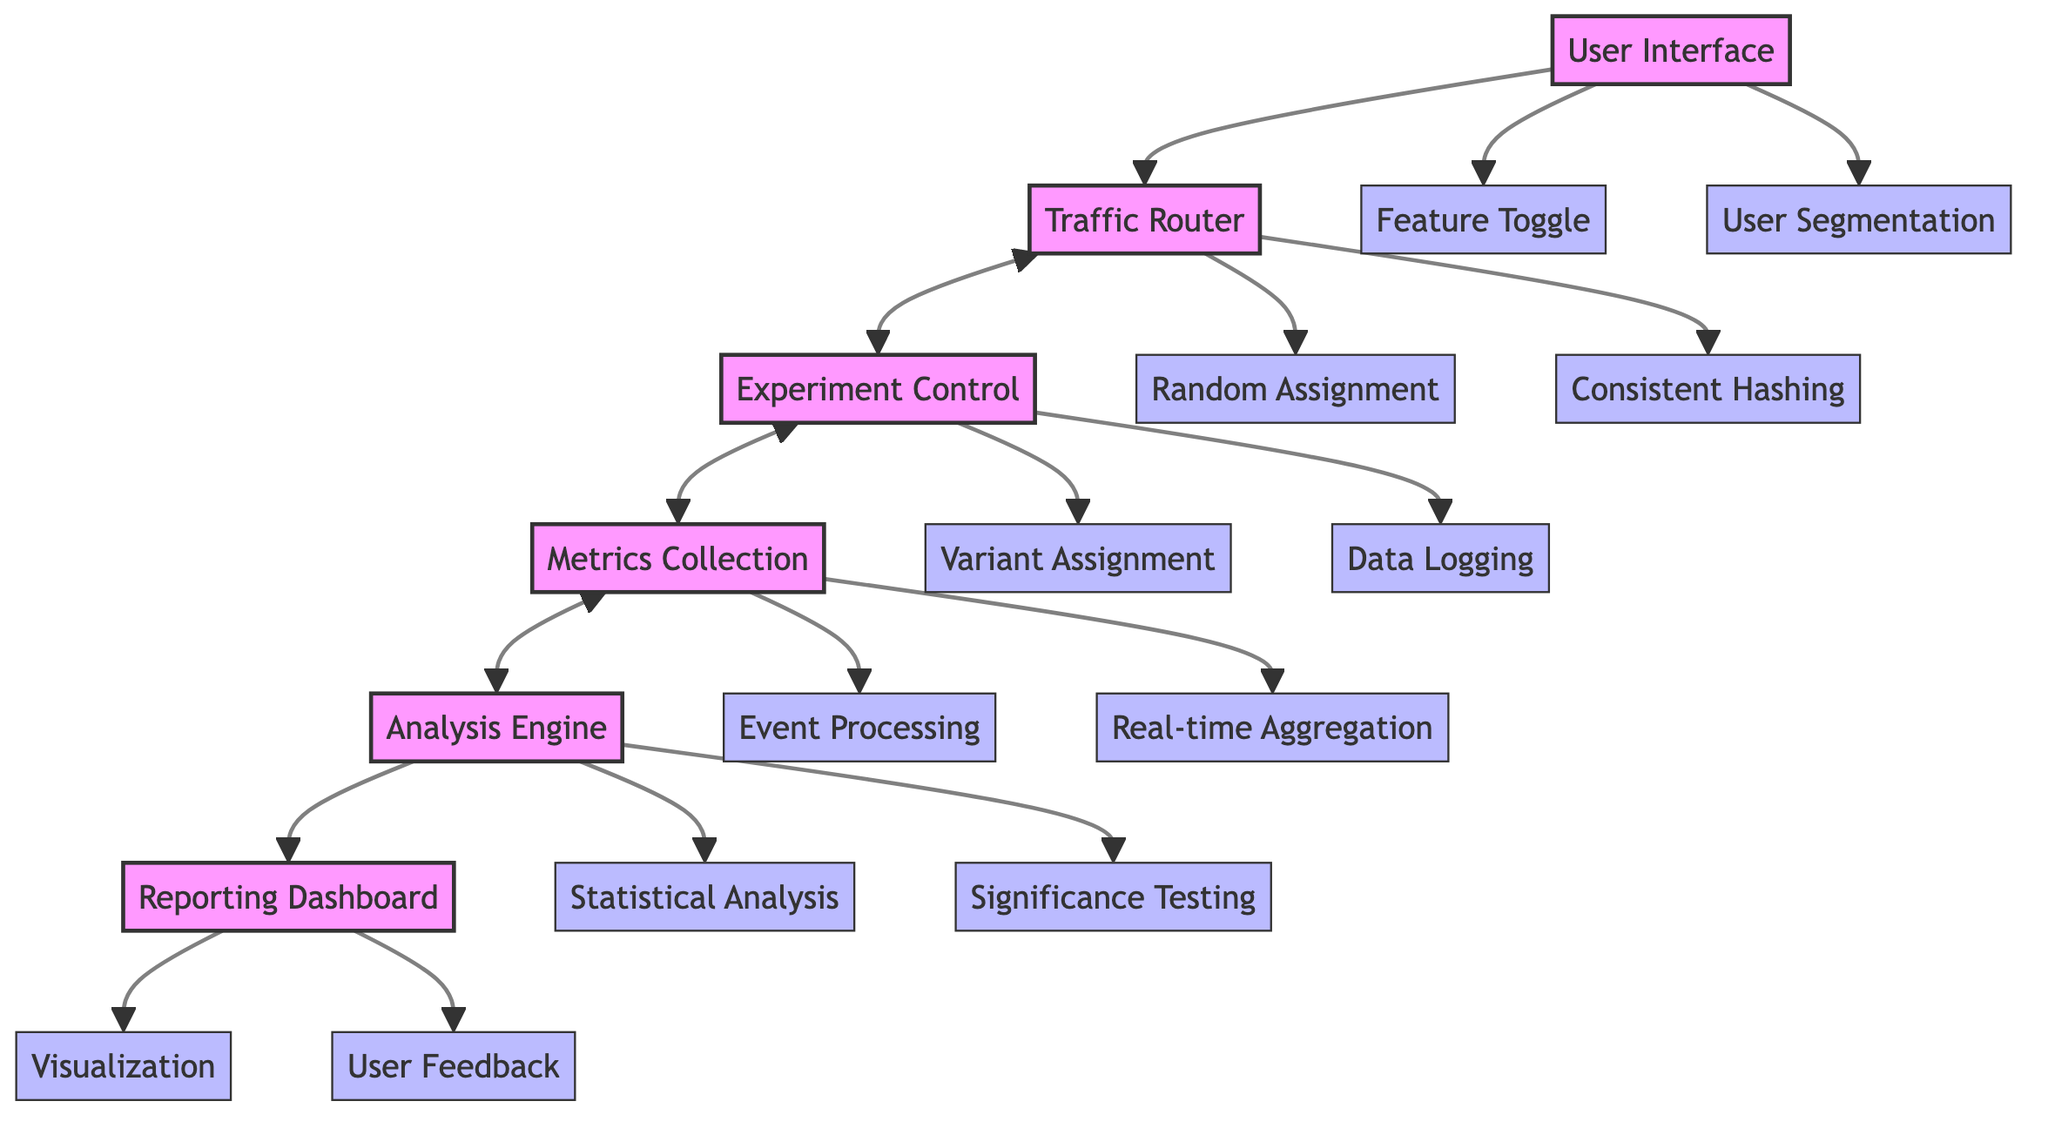What is the main function of the User Interface? The User Interface primarily allows for the implementation of a Feature Toggle and User Segmentation, which are its main attributes. It interacts directly with the Traffic Router.
Answer: Feature Toggle, User Segmentation How many main components are present in the diagram? By counting the components depicted in the diagram, there are six main components: User Interface, Traffic Router, Experiment Control, Metrics Collection, Analysis Engine, and Reporting Dashboard.
Answer: Six Which component is responsible for Data Logging? The Experiment Control component is responsible for Data Logging, as indicated by its listed attributes. It has a bidirectional interaction with the Traffic Router.
Answer: Experiment Control What does the Analysis Engine interact with? The Analysis Engine interacts with both the Metrics Collection and the Reporting Dashboard components, as shown by the arrows connecting them in the diagram.
Answer: Metrics Collection, Reporting Dashboard What are the two attributes of the Metrics Collection component? The two attributes associated with the Metrics Collection component are Event Processing and Real-time Aggregation, which are indicated in the diagram.
Answer: Event Processing, Real-time Aggregation How are the Traffic Router and Experiment Control connected? The Traffic Router and Experiment Control are connected by a bidirectional interaction arrow, meaning they communicate back and forth in the framework process.
Answer: Bidirectional interaction Which attribute is part of the User Interface? The attributes associated with the User Interface include Feature Toggle and User Segmentation, showing how users can interact with features.
Answer: Feature Toggle What key function does the Reporting Dashboard provide? The Reporting Dashboard provides Visualization and User Feedback, allowing users to see results and provide input. This indicates its role in the overall A/B Testing process.
Answer: Visualization, User Feedback Which component is responsible for Random Assignment? The Traffic Router is responsible for Random Assignment, as this is one of its primary attributes displayed in the diagram.
Answer: Traffic Router 